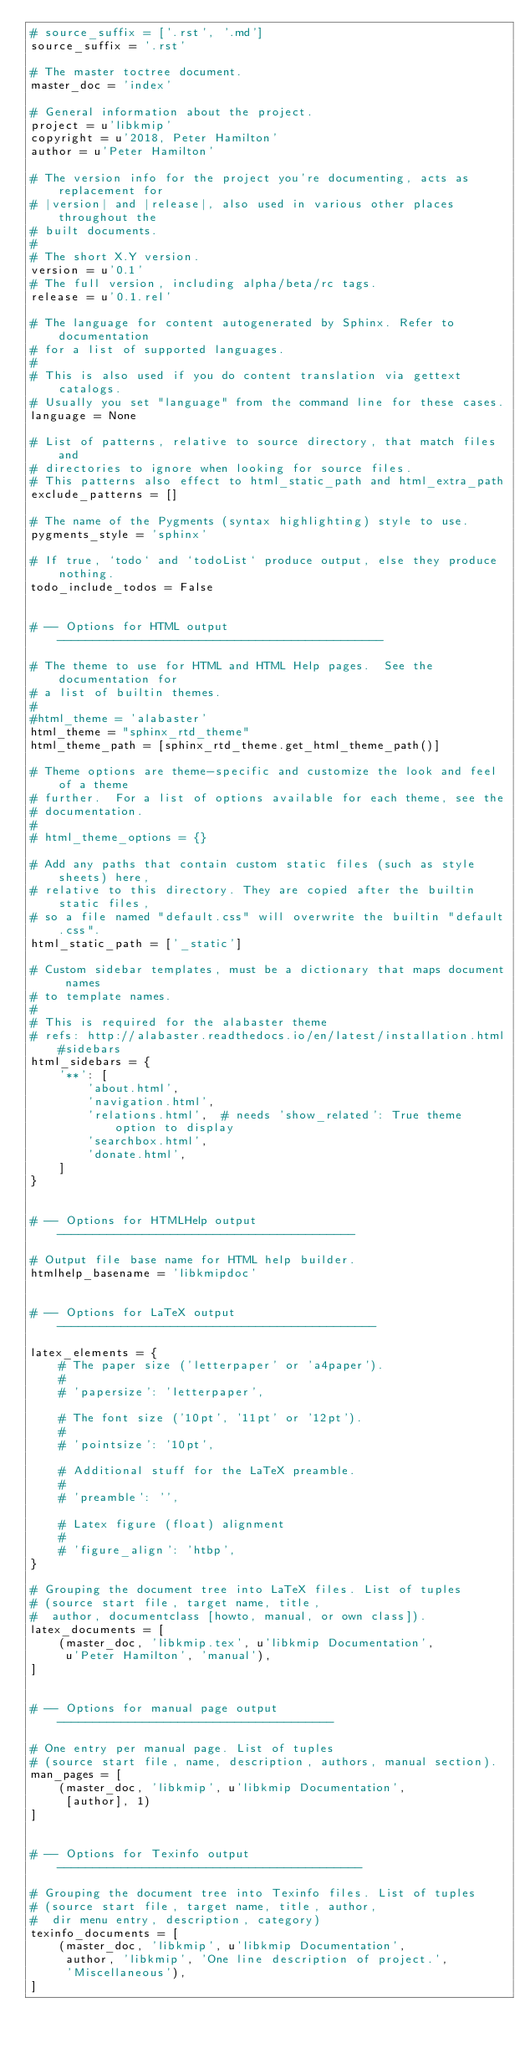<code> <loc_0><loc_0><loc_500><loc_500><_Python_># source_suffix = ['.rst', '.md']
source_suffix = '.rst'

# The master toctree document.
master_doc = 'index'

# General information about the project.
project = u'libkmip'
copyright = u'2018, Peter Hamilton'
author = u'Peter Hamilton'

# The version info for the project you're documenting, acts as replacement for
# |version| and |release|, also used in various other places throughout the
# built documents.
#
# The short X.Y version.
version = u'0.1'
# The full version, including alpha/beta/rc tags.
release = u'0.1.rel'

# The language for content autogenerated by Sphinx. Refer to documentation
# for a list of supported languages.
#
# This is also used if you do content translation via gettext catalogs.
# Usually you set "language" from the command line for these cases.
language = None

# List of patterns, relative to source directory, that match files and
# directories to ignore when looking for source files.
# This patterns also effect to html_static_path and html_extra_path
exclude_patterns = []

# The name of the Pygments (syntax highlighting) style to use.
pygments_style = 'sphinx'

# If true, `todo` and `todoList` produce output, else they produce nothing.
todo_include_todos = False


# -- Options for HTML output ----------------------------------------------

# The theme to use for HTML and HTML Help pages.  See the documentation for
# a list of builtin themes.
#
#html_theme = 'alabaster'
html_theme = "sphinx_rtd_theme"
html_theme_path = [sphinx_rtd_theme.get_html_theme_path()]

# Theme options are theme-specific and customize the look and feel of a theme
# further.  For a list of options available for each theme, see the
# documentation.
#
# html_theme_options = {}

# Add any paths that contain custom static files (such as style sheets) here,
# relative to this directory. They are copied after the builtin static files,
# so a file named "default.css" will overwrite the builtin "default.css".
html_static_path = ['_static']

# Custom sidebar templates, must be a dictionary that maps document names
# to template names.
#
# This is required for the alabaster theme
# refs: http://alabaster.readthedocs.io/en/latest/installation.html#sidebars
html_sidebars = {
    '**': [
        'about.html',
        'navigation.html',
        'relations.html',  # needs 'show_related': True theme option to display
        'searchbox.html',
        'donate.html',
    ]
}


# -- Options for HTMLHelp output ------------------------------------------

# Output file base name for HTML help builder.
htmlhelp_basename = 'libkmipdoc'


# -- Options for LaTeX output ---------------------------------------------

latex_elements = {
    # The paper size ('letterpaper' or 'a4paper').
    #
    # 'papersize': 'letterpaper',

    # The font size ('10pt', '11pt' or '12pt').
    #
    # 'pointsize': '10pt',

    # Additional stuff for the LaTeX preamble.
    #
    # 'preamble': '',

    # Latex figure (float) alignment
    #
    # 'figure_align': 'htbp',
}

# Grouping the document tree into LaTeX files. List of tuples
# (source start file, target name, title,
#  author, documentclass [howto, manual, or own class]).
latex_documents = [
    (master_doc, 'libkmip.tex', u'libkmip Documentation',
     u'Peter Hamilton', 'manual'),
]


# -- Options for manual page output ---------------------------------------

# One entry per manual page. List of tuples
# (source start file, name, description, authors, manual section).
man_pages = [
    (master_doc, 'libkmip', u'libkmip Documentation',
     [author], 1)
]


# -- Options for Texinfo output -------------------------------------------

# Grouping the document tree into Texinfo files. List of tuples
# (source start file, target name, title, author,
#  dir menu entry, description, category)
texinfo_documents = [
    (master_doc, 'libkmip', u'libkmip Documentation',
     author, 'libkmip', 'One line description of project.',
     'Miscellaneous'),
]



</code> 